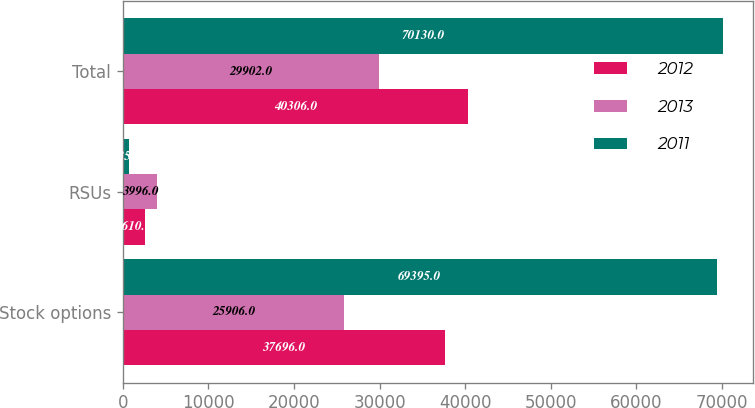Convert chart to OTSL. <chart><loc_0><loc_0><loc_500><loc_500><stacked_bar_chart><ecel><fcel>Stock options<fcel>RSUs<fcel>Total<nl><fcel>2012<fcel>37696<fcel>2610<fcel>40306<nl><fcel>2013<fcel>25906<fcel>3996<fcel>29902<nl><fcel>2011<fcel>69395<fcel>735<fcel>70130<nl></chart> 